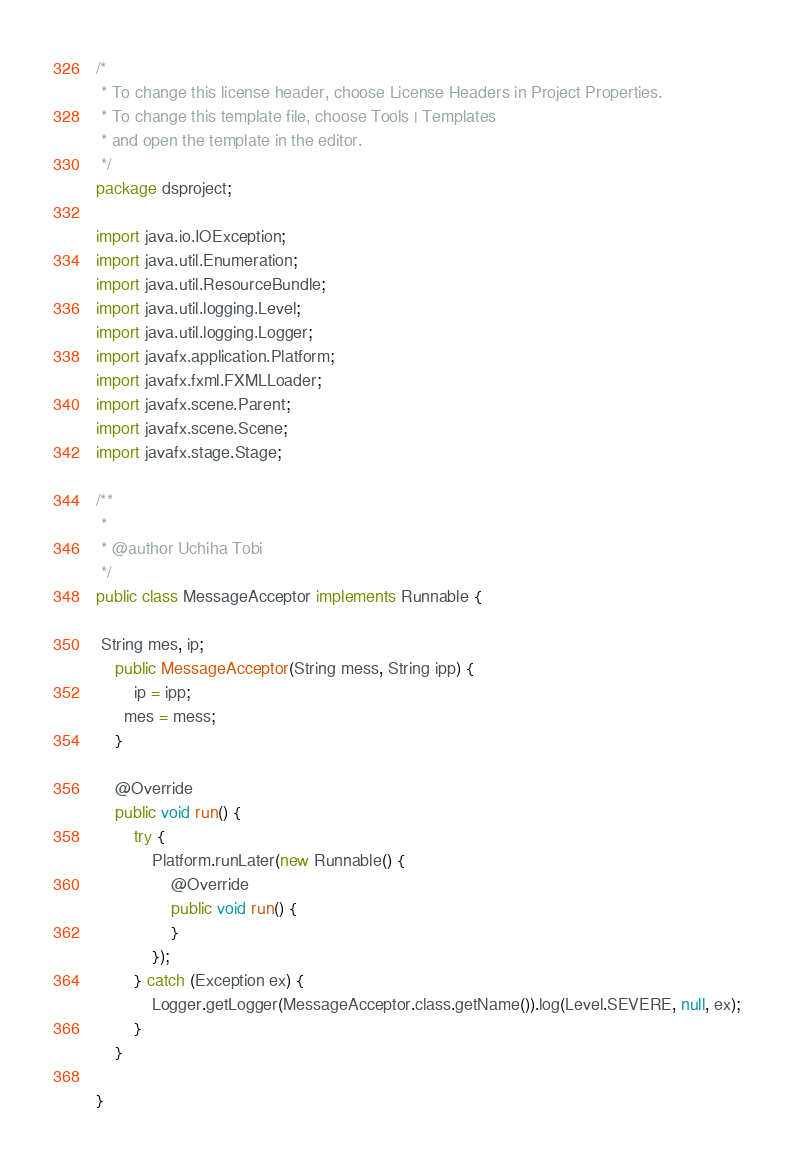Convert code to text. <code><loc_0><loc_0><loc_500><loc_500><_Java_>/*
 * To change this license header, choose License Headers in Project Properties.
 * To change this template file, choose Tools | Templates
 * and open the template in the editor.
 */
package dsproject;

import java.io.IOException;
import java.util.Enumeration;
import java.util.ResourceBundle;
import java.util.logging.Level;
import java.util.logging.Logger;
import javafx.application.Platform;
import javafx.fxml.FXMLLoader;
import javafx.scene.Parent;
import javafx.scene.Scene;
import javafx.stage.Stage;

/**
 *
 * @author Uchiha Tobi
 */
public class MessageAcceptor implements Runnable {

 String mes, ip;
    public MessageAcceptor(String mess, String ipp) {
        ip = ipp;
      mes = mess; 
    }

    @Override
    public void run() {
        try {
            Platform.runLater(new Runnable() {
                @Override
                public void run() {
                }
            });
        } catch (Exception ex) {
            Logger.getLogger(MessageAcceptor.class.getName()).log(Level.SEVERE, null, ex);
        }
    }

}
</code> 